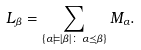Convert formula to latex. <formula><loc_0><loc_0><loc_500><loc_500>L _ { \beta } = \sum _ { \{ \alpha \models | \beta | \colon \, \alpha \preceq \beta \} } M _ { \alpha } .</formula> 